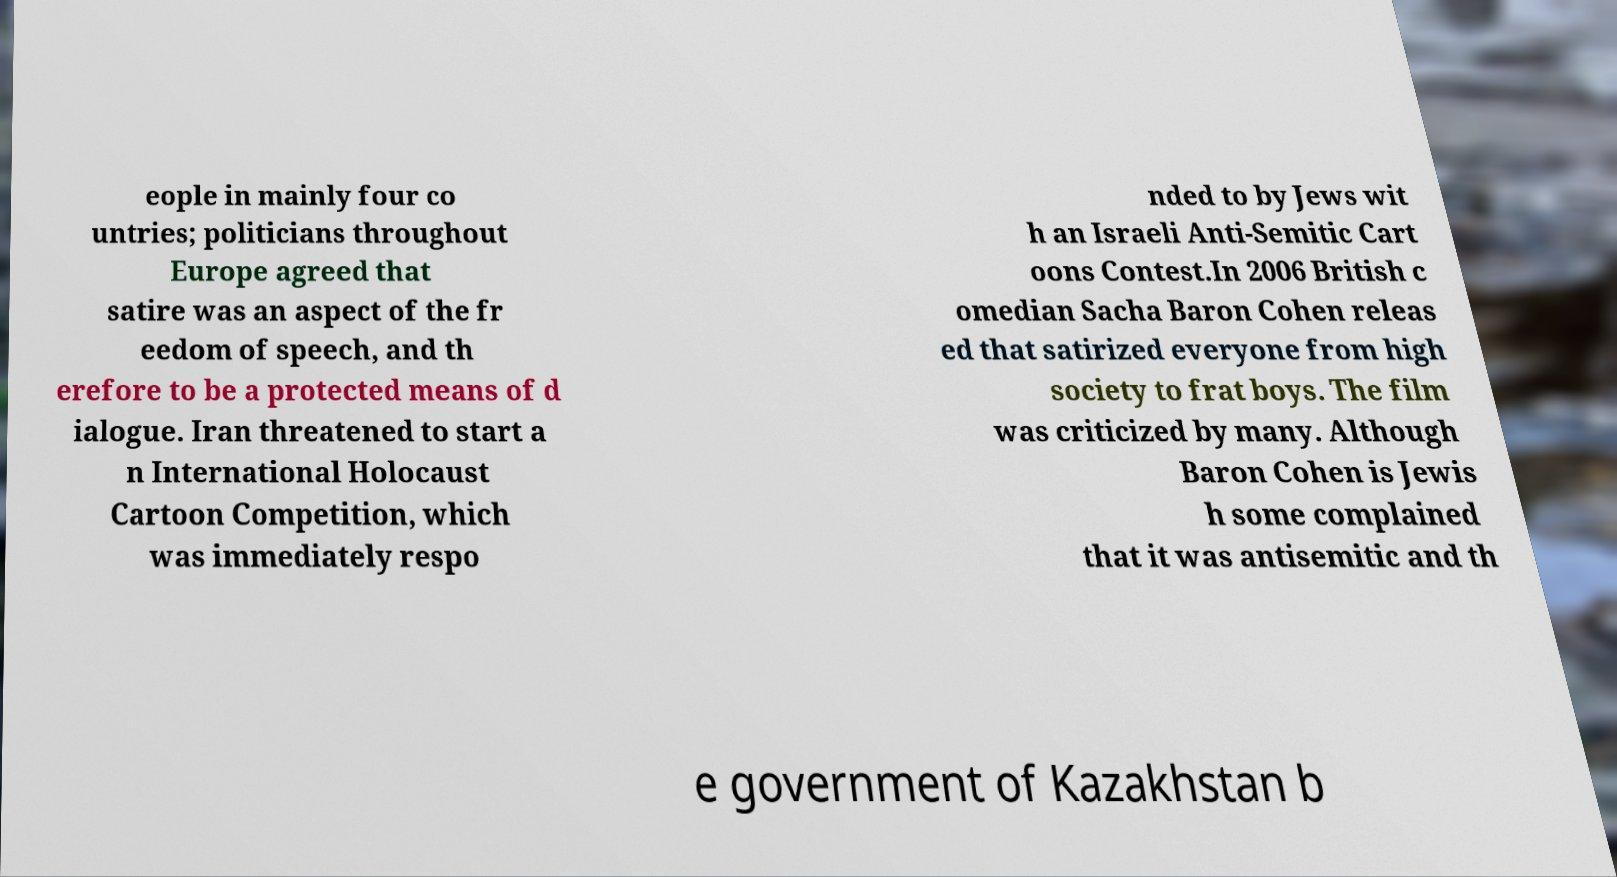Could you assist in decoding the text presented in this image and type it out clearly? eople in mainly four co untries; politicians throughout Europe agreed that satire was an aspect of the fr eedom of speech, and th erefore to be a protected means of d ialogue. Iran threatened to start a n International Holocaust Cartoon Competition, which was immediately respo nded to by Jews wit h an Israeli Anti-Semitic Cart oons Contest.In 2006 British c omedian Sacha Baron Cohen releas ed that satirized everyone from high society to frat boys. The film was criticized by many. Although Baron Cohen is Jewis h some complained that it was antisemitic and th e government of Kazakhstan b 